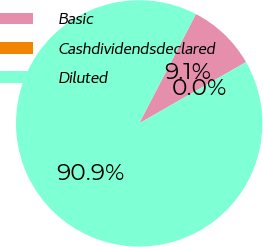<chart> <loc_0><loc_0><loc_500><loc_500><pie_chart><fcel>Basic<fcel>Cashdividendsdeclared<fcel>Diluted<nl><fcel>9.09%<fcel>0.0%<fcel>90.91%<nl></chart> 